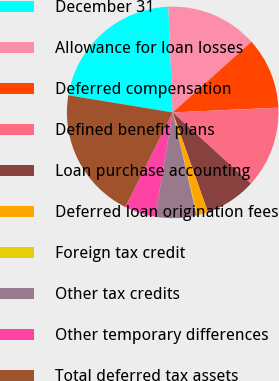Convert chart. <chart><loc_0><loc_0><loc_500><loc_500><pie_chart><fcel>December 31<fcel>Allowance for loan losses<fcel>Deferred compensation<fcel>Defined benefit plans<fcel>Loan purchase accounting<fcel>Deferred loan origination fees<fcel>Foreign tax credit<fcel>Other tax credits<fcel>Other temporary differences<fcel>Total deferred tax assets<nl><fcel>21.75%<fcel>14.02%<fcel>10.93%<fcel>12.47%<fcel>7.84%<fcel>1.65%<fcel>0.11%<fcel>6.29%<fcel>4.75%<fcel>20.2%<nl></chart> 